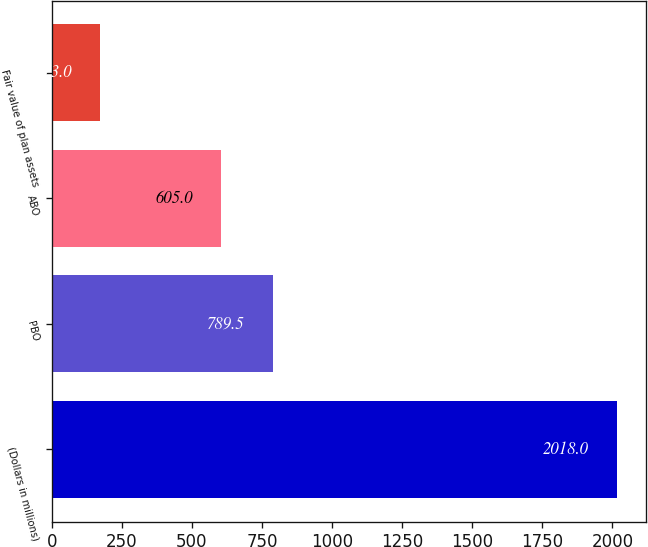<chart> <loc_0><loc_0><loc_500><loc_500><bar_chart><fcel>(Dollars in millions)<fcel>PBO<fcel>ABO<fcel>Fair value of plan assets<nl><fcel>2018<fcel>789.5<fcel>605<fcel>173<nl></chart> 